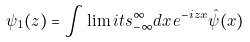Convert formula to latex. <formula><loc_0><loc_0><loc_500><loc_500>{ \psi } _ { 1 } ( z ) = \int \lim i t s _ { - \infty } ^ { \infty } d x \, e ^ { - i z x } \hat { \psi } ( x )</formula> 